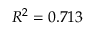Convert formula to latex. <formula><loc_0><loc_0><loc_500><loc_500>R ^ { 2 } = 0 . 7 1 3</formula> 